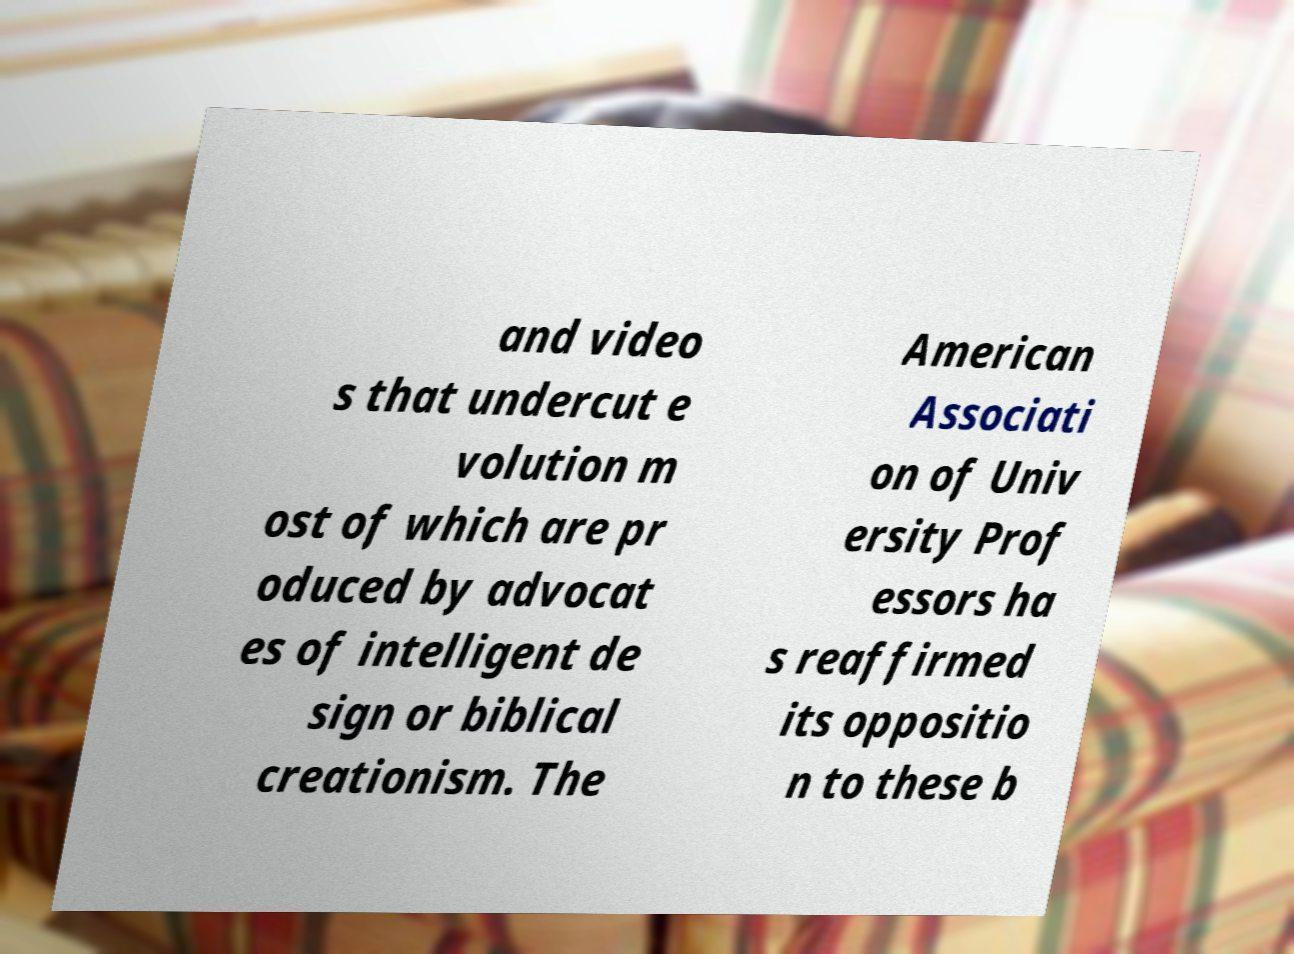There's text embedded in this image that I need extracted. Can you transcribe it verbatim? and video s that undercut e volution m ost of which are pr oduced by advocat es of intelligent de sign or biblical creationism. The American Associati on of Univ ersity Prof essors ha s reaffirmed its oppositio n to these b 